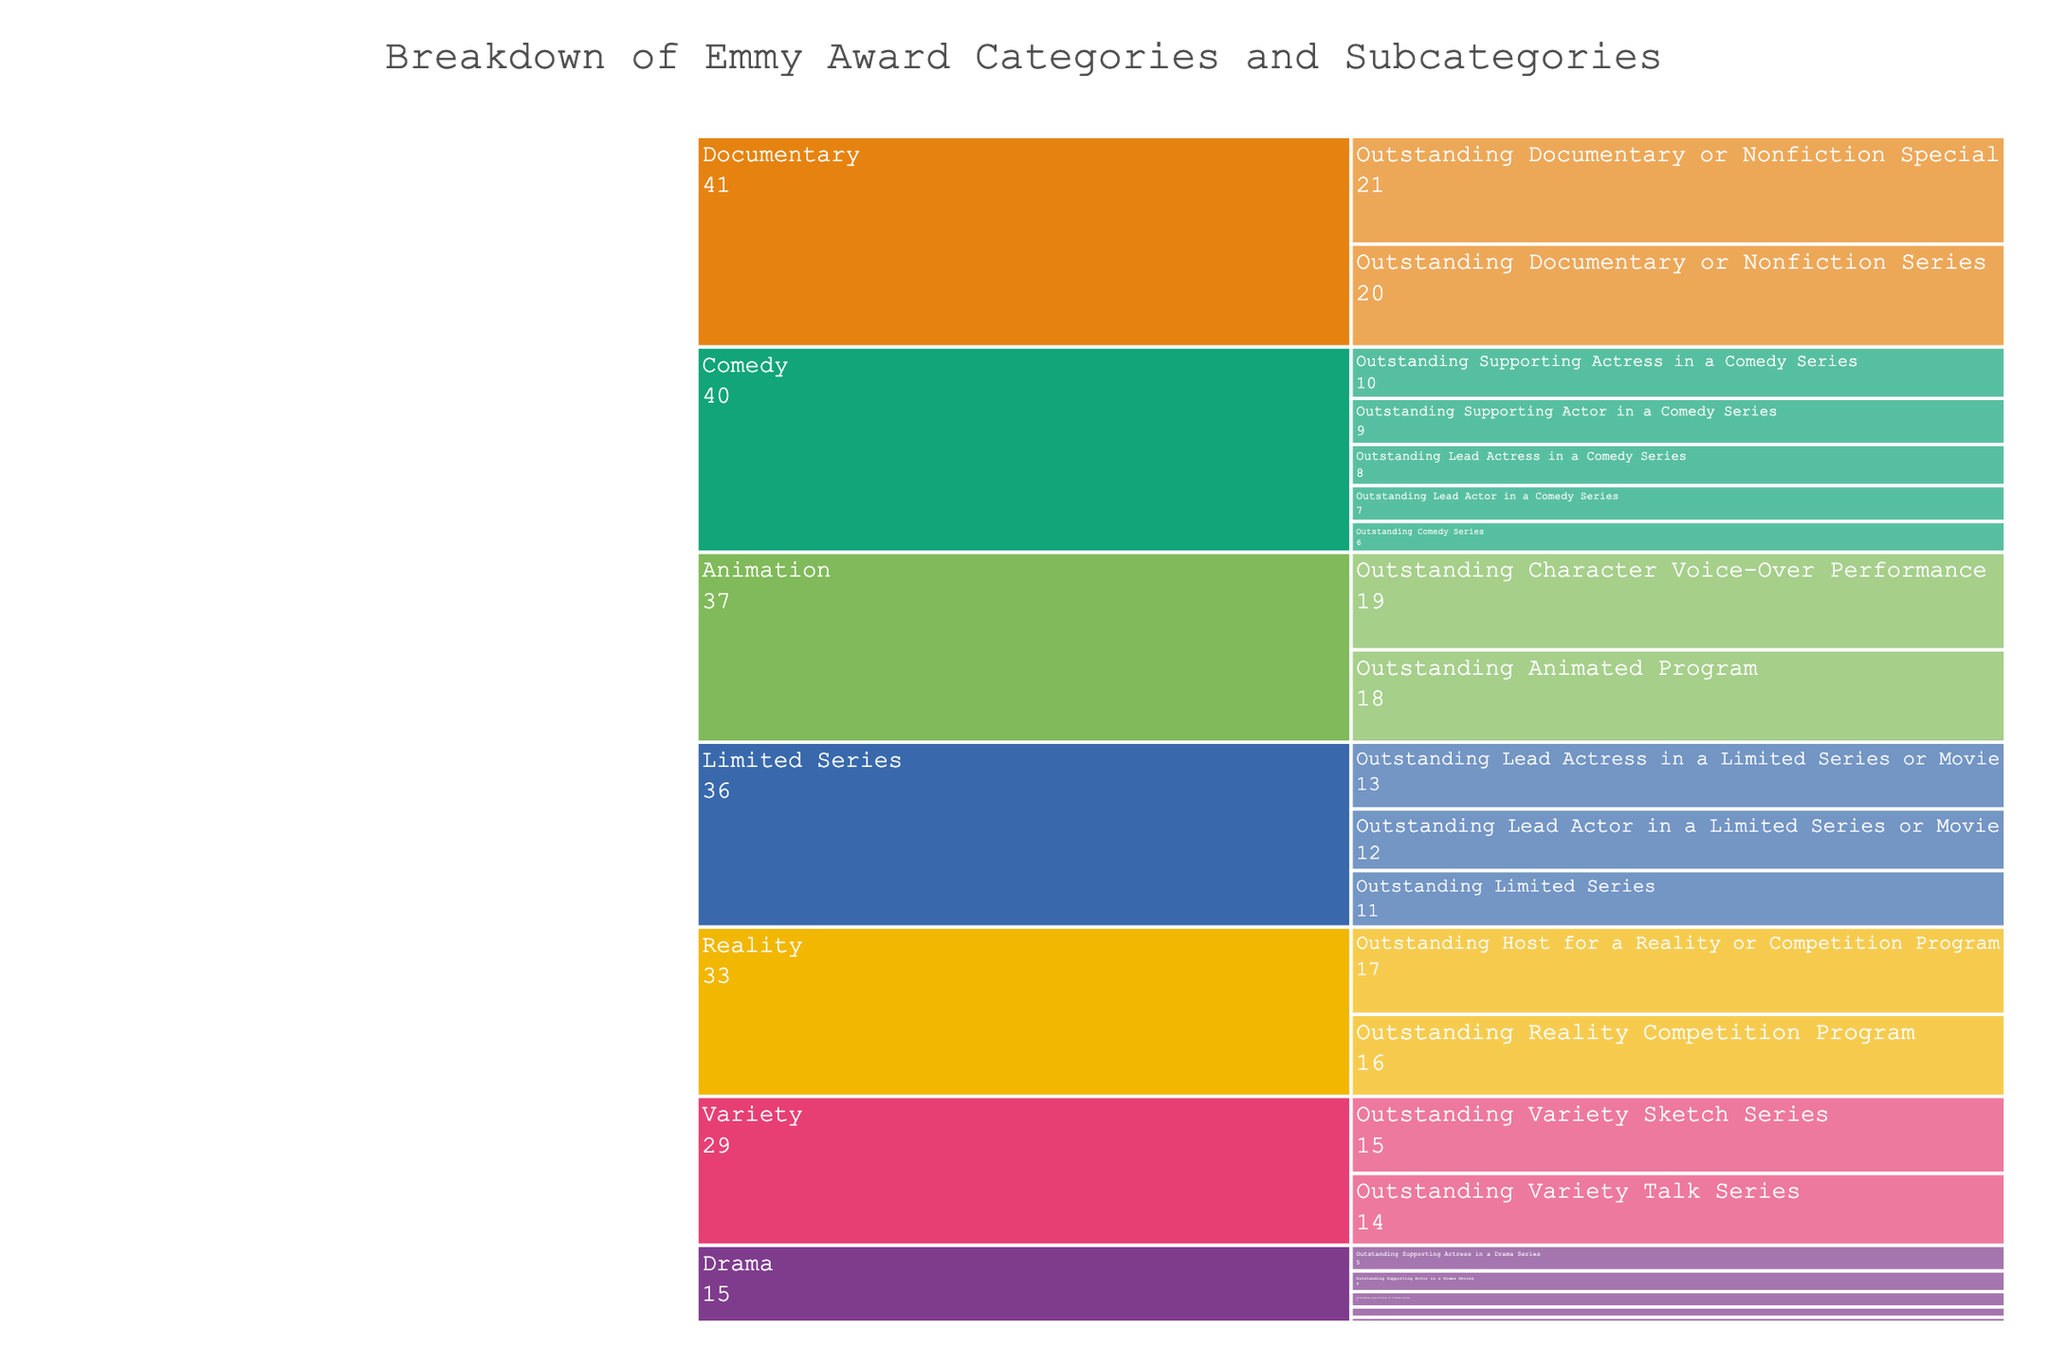what is the title of the icicle chart? The title is clearly displayed at the top center of the chart.
Answer: Breakdown of Emmy Award Categories and Subcategories How many categories are recognized in the Emmy Awards according to the chart? Count the different main branches in the chart, each representing a different category.
Answer: 6 Which category has the most subcategories? Compare the number of subcategories under each main category to identify which has the most.
Answer: Drama What is the combined total of awards for the Drama and Comedy categories? Add up the awards for subcategories under Drama (1+2+3+4+5) and Comedy (6+7+8+9+10) and then sum the two totals.
Answer: 55 Is the total number of awards given in the Animation category less than the total in the Variety category? Compare the sum of awards for Animation (18+19) with Variety (14+15).
Answer: Yes What is the value for the 'Outstanding Lead Actress in a Comedy Series' award? Identify the corresponding subcategory in the Comedy category and note its value.
Answer: 8 Which category has a subcategory named 'Outstanding Documentary or Nonfiction Special'? Trace the subcategory to its parent category in the chart.
Answer: Documentary How does the number of awards in the Reality category compare to the Animation category? Sum the awards in each category: Reality (16+17), Animation (18+19). Compare the totals.
Answer: Equal What is the difference between the total awards for the Drama and Limited Series categories? Calculate the sum for Drama (1+2+3+4+5) and Limited Series (11+12+13), then find the difference.
Answer: 8 Which category has fewer total awards, Documentary or Reality? Compare the sums of awards in Documentary (20+21) and Reality (16+17).
Answer: Documentary 